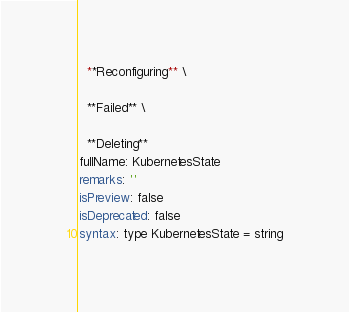Convert code to text. <code><loc_0><loc_0><loc_500><loc_500><_YAML_>  **Reconfiguring** \

  **Failed** \

  **Deleting**
fullName: KubernetesState
remarks: ''
isPreview: false
isDeprecated: false
syntax: type KubernetesState = string
</code> 